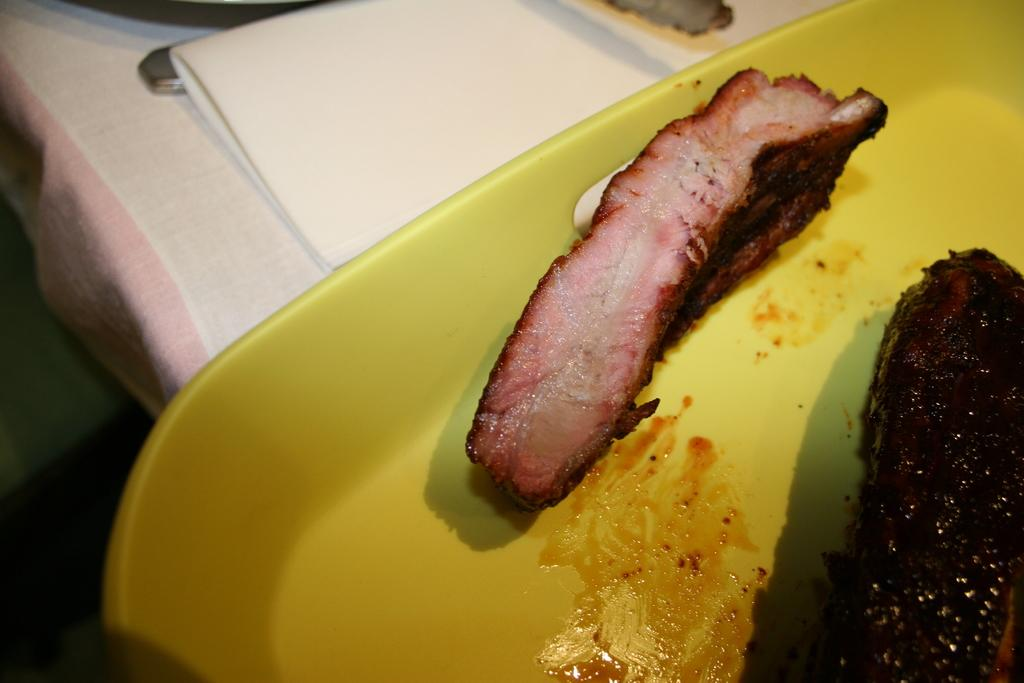What type of food can be seen in the image? The food in the image is in brown color. What is the color of the plate on which the food is placed? The food is on a yellow color plate. Can you describe the objects in the background of the image? The objects in the background are white in color. What type of authority figure can be seen in the image? There is no authority figure present in the image. Can you describe the rake that is being used to tend to the volcano in the image? There is no rake or volcano present in the image. 